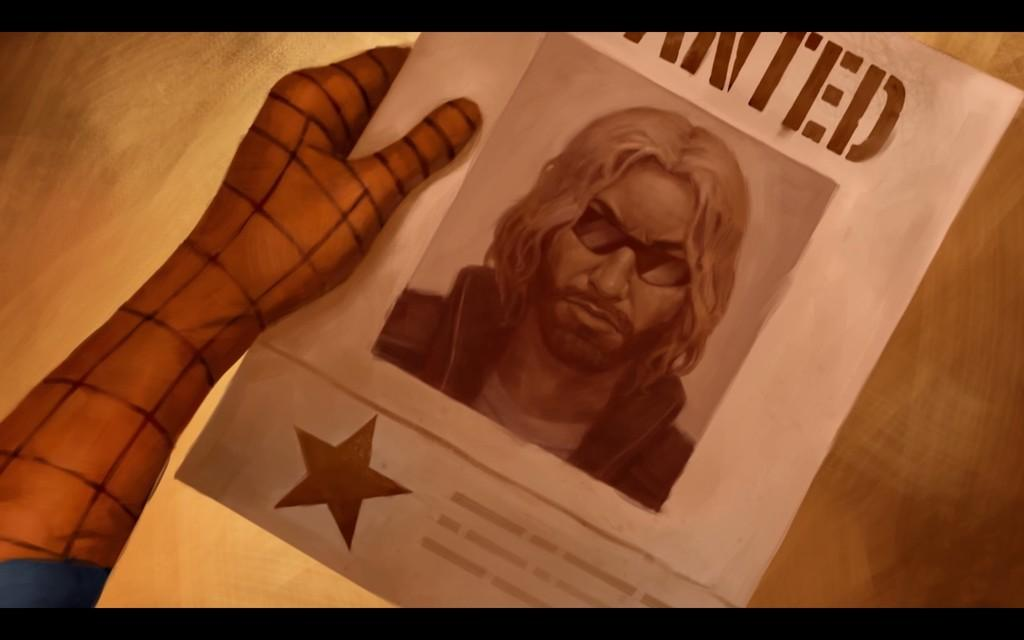<image>
Provide a brief description of the given image. Poster showing a man wearing sunglasses that is wanted. 